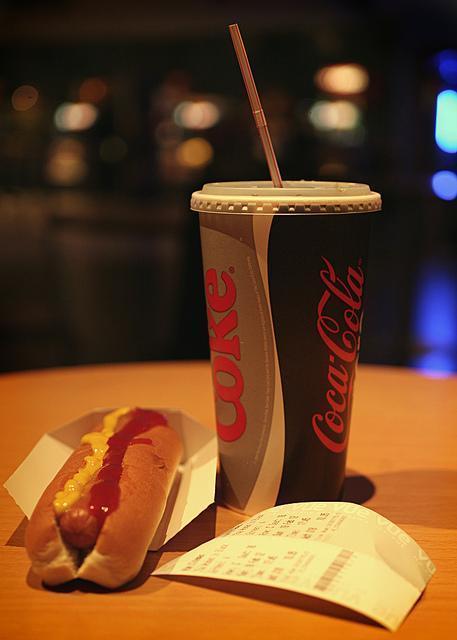How many dining tables are there?
Give a very brief answer. 1. How many buses  are in the photo?
Give a very brief answer. 0. 